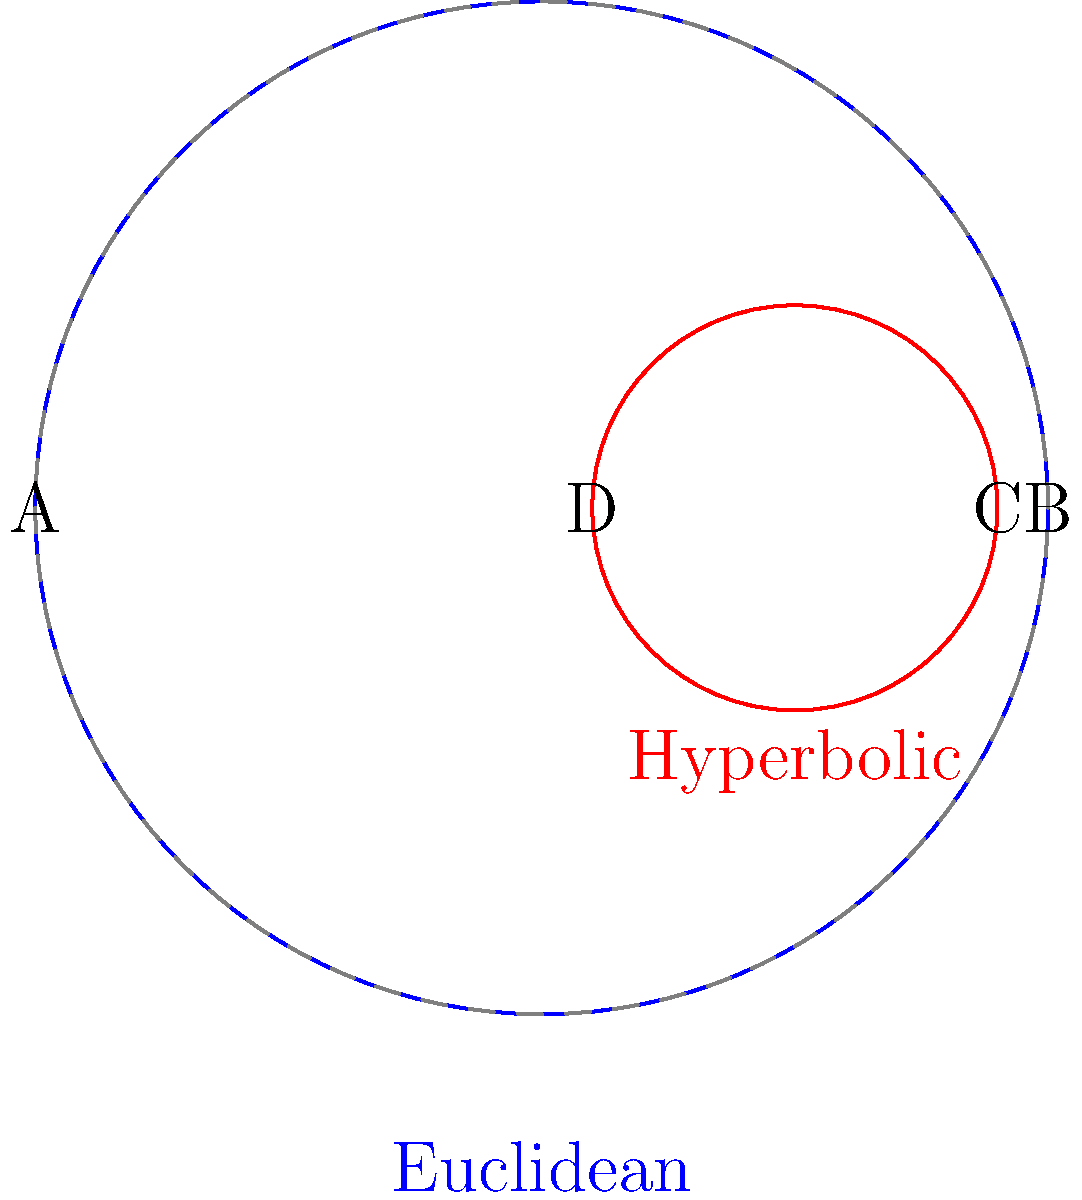In your cosplay transformations, you often use circular patterns for dramatic effect. Consider the properties of circles in different geometries. The blue circle represents a circle in Euclidean geometry, while the red circle represents a circle in hyperbolic geometry (using the Poincaré disk model). If the diameter AB of the Euclidean circle is equal to the diameter CD of the hyperbolic circle, how does the circumference of the hyperbolic circle compare to that of the Euclidean circle? Let's approach this step-by-step:

1) In Euclidean geometry, the ratio of a circle's circumference to its diameter is always constant (π).

2) In hyperbolic geometry, this ratio is always greater than π.

3) The formula for the circumference of a circle in hyperbolic geometry is:

   $$C = 2π \sinh(r)$$

   where r is the hyperbolic radius.

4) In Euclidean geometry, the formula is:

   $$C = 2πr$$

5) For the same diameter, the hyperbolic sinh(r) will always be greater than the Euclidean r.

6) This means that for equal diameters, the circumference of the hyperbolic circle will always be greater than that of the Euclidean circle.

7) Visually, we can see that the red hyperbolic circle appears "puffed up" compared to what a Euclidean circle of the same diameter would look like in that position.

This property could be creatively used in makeup designs, where circular patterns near the edge of the face could be intentionally distorted to create a hyperbolic-like effect, giving an otherworldly or dramatic appearance.
Answer: The hyperbolic circle's circumference is greater than the Euclidean circle's circumference. 